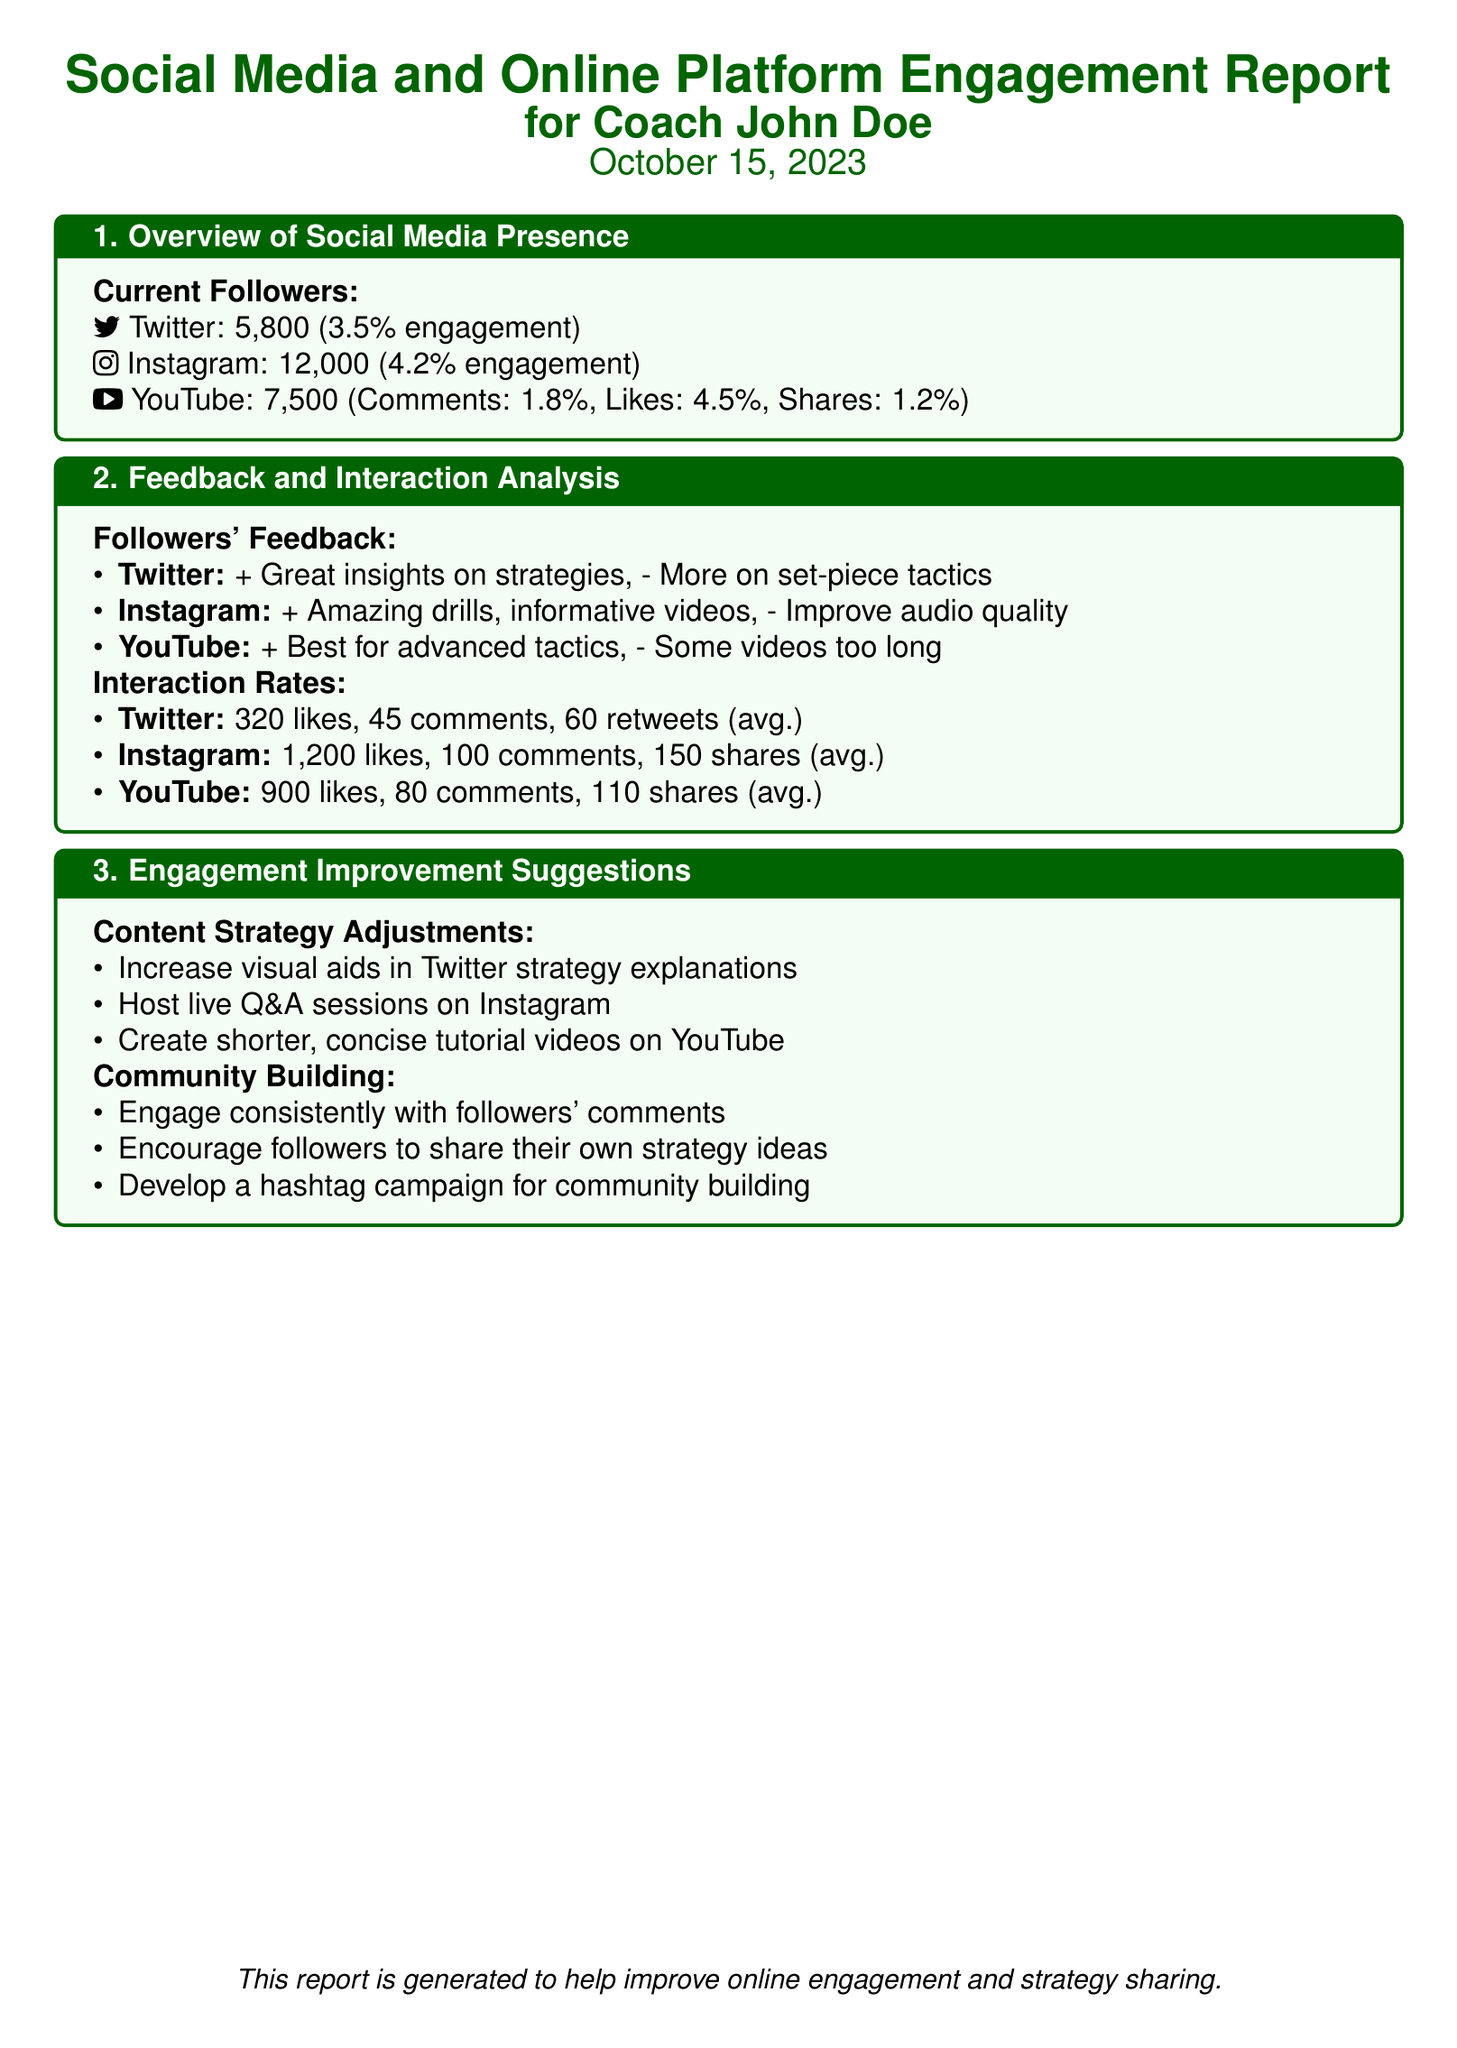What is the Twitter follower count? The Twitter follower count is stated in the overview, which lists the current followers on different platforms.
Answer: 5,800 What is the engagement rate for Instagram? The engagement rate for Instagram is one of the metrics provided in the overview section.
Answer: 4.2% What feedback did followers provide about YouTube videos? The document lists specific positive and negative feedback about YouTube under followers' feedback.
Answer: Some videos too long What is the average number of comments on Instagram? The average number of comments for Instagram is included in the interaction rates section.
Answer: 100 Which platform had the highest number of likes? The average likes are listed for each platform, allowing for a comparison.
Answer: Instagram What is one suggestion to improve Twitter content strategy? The engagement improvement suggestions provide specific actions for each platform's content strategy adjustments.
Answer: Increase visual aids What unique idea is suggested for community building? The community building section offers unique strategies to enhance follower engagement.
Answer: Develop a hashtag campaign How many shares does YouTube average? The average shares for YouTube are part of the interaction rates in the report.
Answer: 110 What specific feedback do followers want more of on Twitter? The followers' feedback section contains requests for additional content on Twitter specifically.
Answer: More on set-piece tactics 